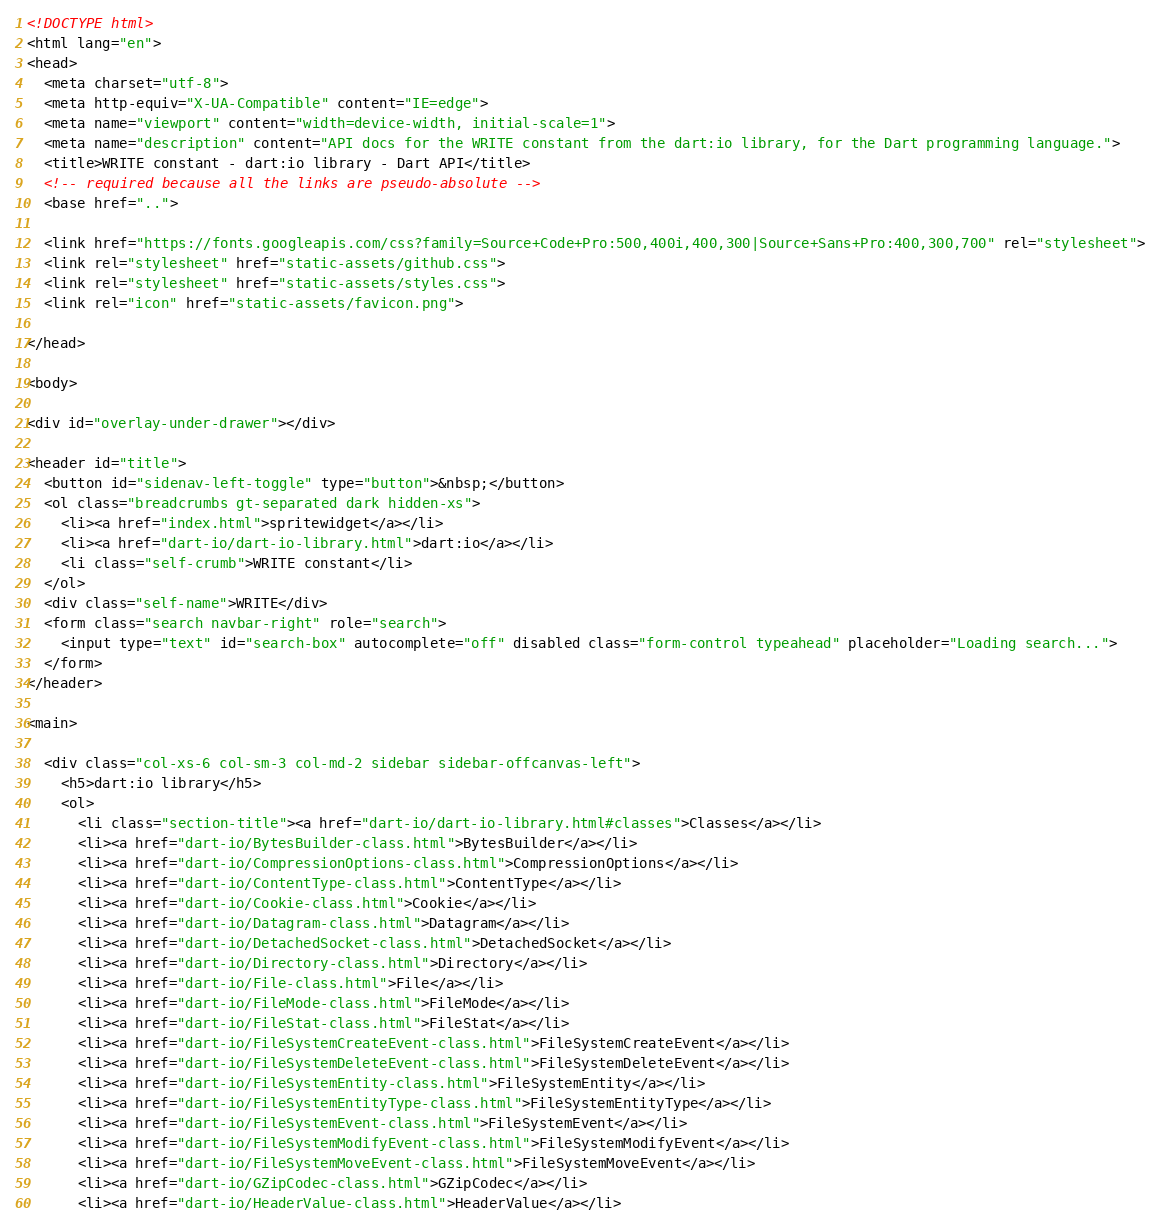<code> <loc_0><loc_0><loc_500><loc_500><_HTML_><!DOCTYPE html>
<html lang="en">
<head>
  <meta charset="utf-8">
  <meta http-equiv="X-UA-Compatible" content="IE=edge">
  <meta name="viewport" content="width=device-width, initial-scale=1">
  <meta name="description" content="API docs for the WRITE constant from the dart:io library, for the Dart programming language.">
  <title>WRITE constant - dart:io library - Dart API</title>
  <!-- required because all the links are pseudo-absolute -->
  <base href="..">

  <link href="https://fonts.googleapis.com/css?family=Source+Code+Pro:500,400i,400,300|Source+Sans+Pro:400,300,700" rel="stylesheet">
  <link rel="stylesheet" href="static-assets/github.css">
  <link rel="stylesheet" href="static-assets/styles.css">
  <link rel="icon" href="static-assets/favicon.png">

</head>

<body>

<div id="overlay-under-drawer"></div>

<header id="title">
  <button id="sidenav-left-toggle" type="button">&nbsp;</button>
  <ol class="breadcrumbs gt-separated dark hidden-xs">
    <li><a href="index.html">spritewidget</a></li>
    <li><a href="dart-io/dart-io-library.html">dart:io</a></li>
    <li class="self-crumb">WRITE constant</li>
  </ol>
  <div class="self-name">WRITE</div>
  <form class="search navbar-right" role="search">
    <input type="text" id="search-box" autocomplete="off" disabled class="form-control typeahead" placeholder="Loading search...">
  </form>
</header>

<main>

  <div class="col-xs-6 col-sm-3 col-md-2 sidebar sidebar-offcanvas-left">
    <h5>dart:io library</h5>
    <ol>
      <li class="section-title"><a href="dart-io/dart-io-library.html#classes">Classes</a></li>
      <li><a href="dart-io/BytesBuilder-class.html">BytesBuilder</a></li>
      <li><a href="dart-io/CompressionOptions-class.html">CompressionOptions</a></li>
      <li><a href="dart-io/ContentType-class.html">ContentType</a></li>
      <li><a href="dart-io/Cookie-class.html">Cookie</a></li>
      <li><a href="dart-io/Datagram-class.html">Datagram</a></li>
      <li><a href="dart-io/DetachedSocket-class.html">DetachedSocket</a></li>
      <li><a href="dart-io/Directory-class.html">Directory</a></li>
      <li><a href="dart-io/File-class.html">File</a></li>
      <li><a href="dart-io/FileMode-class.html">FileMode</a></li>
      <li><a href="dart-io/FileStat-class.html">FileStat</a></li>
      <li><a href="dart-io/FileSystemCreateEvent-class.html">FileSystemCreateEvent</a></li>
      <li><a href="dart-io/FileSystemDeleteEvent-class.html">FileSystemDeleteEvent</a></li>
      <li><a href="dart-io/FileSystemEntity-class.html">FileSystemEntity</a></li>
      <li><a href="dart-io/FileSystemEntityType-class.html">FileSystemEntityType</a></li>
      <li><a href="dart-io/FileSystemEvent-class.html">FileSystemEvent</a></li>
      <li><a href="dart-io/FileSystemModifyEvent-class.html">FileSystemModifyEvent</a></li>
      <li><a href="dart-io/FileSystemMoveEvent-class.html">FileSystemMoveEvent</a></li>
      <li><a href="dart-io/GZipCodec-class.html">GZipCodec</a></li>
      <li><a href="dart-io/HeaderValue-class.html">HeaderValue</a></li></code> 